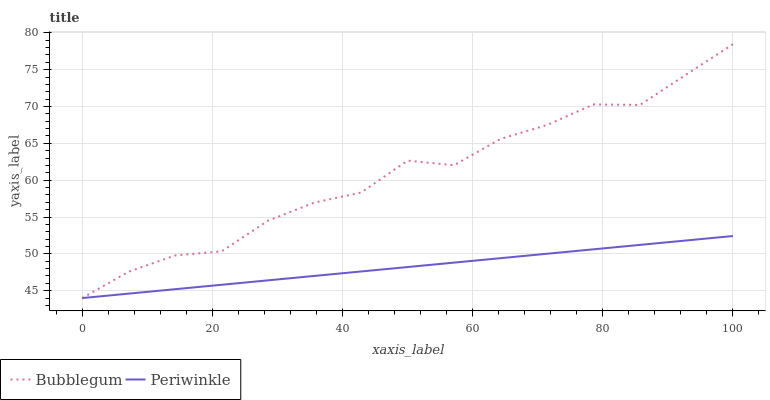Does Periwinkle have the minimum area under the curve?
Answer yes or no. Yes. Does Bubblegum have the maximum area under the curve?
Answer yes or no. Yes. Does Bubblegum have the minimum area under the curve?
Answer yes or no. No. Is Periwinkle the smoothest?
Answer yes or no. Yes. Is Bubblegum the roughest?
Answer yes or no. Yes. Is Bubblegum the smoothest?
Answer yes or no. No. 